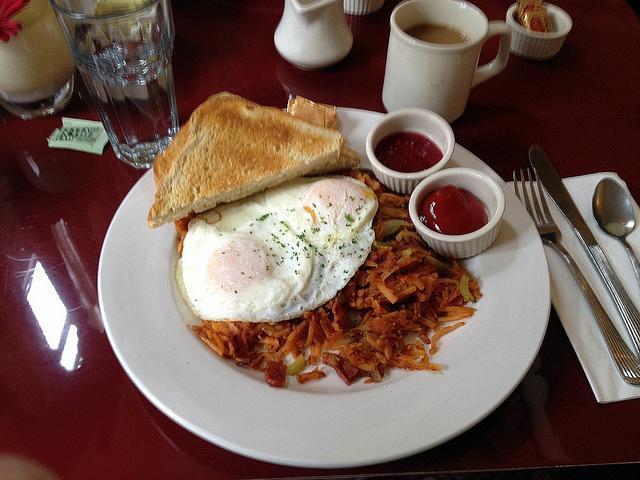How many spoons are on the table?
Give a very brief answer. 1. How many dining tables are there?
Give a very brief answer. 2. How many cups can you see?
Give a very brief answer. 5. How many bowls are visible?
Give a very brief answer. 2. 